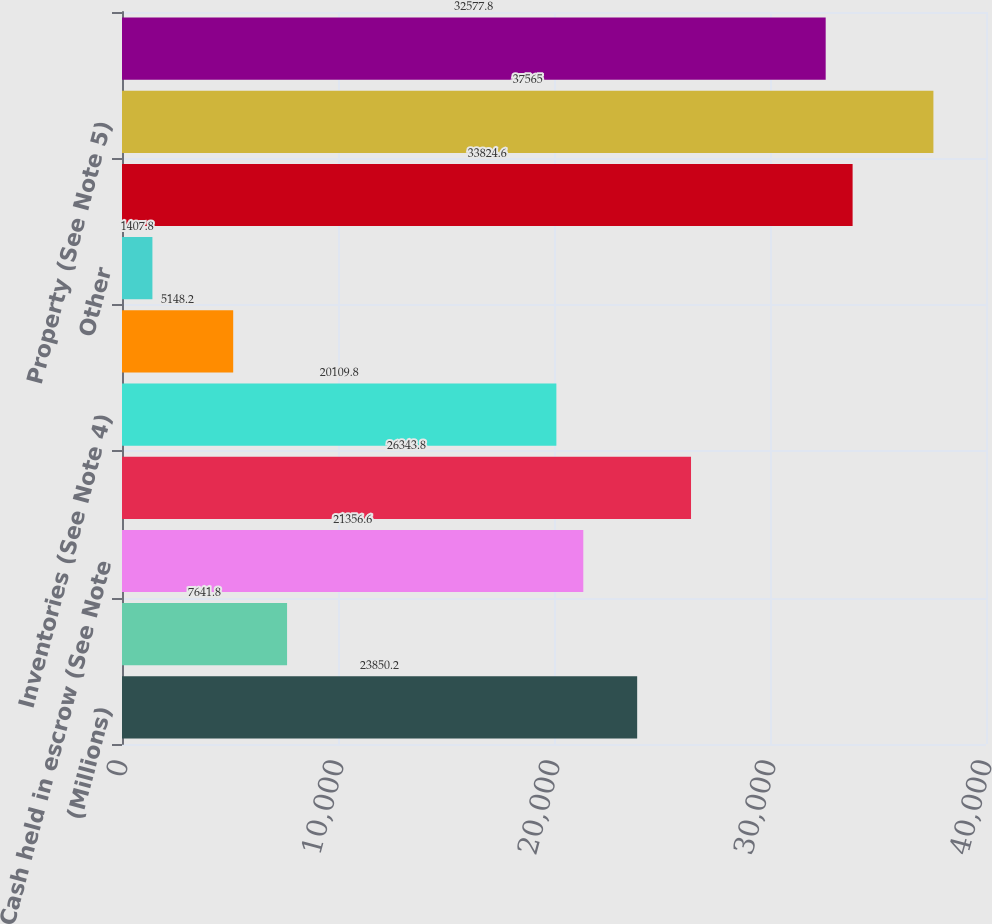Convert chart to OTSL. <chart><loc_0><loc_0><loc_500><loc_500><bar_chart><fcel>(Millions)<fcel>Cash and cash equivalents<fcel>Cash held in escrow (See Note<fcel>Receivables (See Note 4)<fcel>Inventories (See Note 4)<fcel>Deferred income taxes (See<fcel>Other<fcel>Total current assets<fcel>Property (See Note 5)<fcel>Less accumulated depreciation<nl><fcel>23850.2<fcel>7641.8<fcel>21356.6<fcel>26343.8<fcel>20109.8<fcel>5148.2<fcel>1407.8<fcel>33824.6<fcel>37565<fcel>32577.8<nl></chart> 